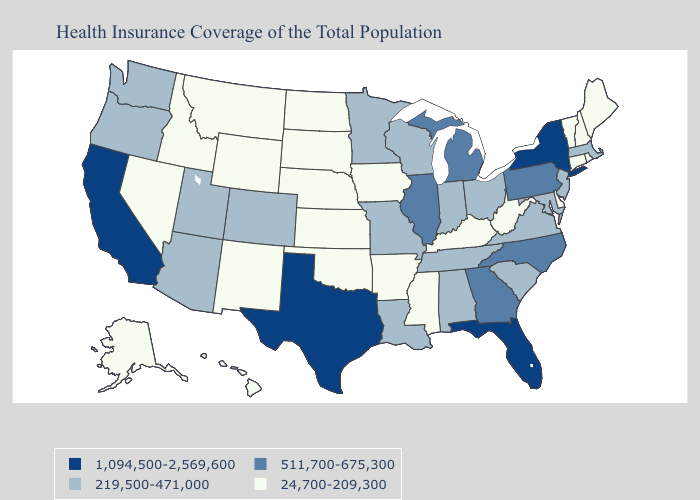Does Pennsylvania have the lowest value in the Northeast?
Be succinct. No. Name the states that have a value in the range 1,094,500-2,569,600?
Be succinct. California, Florida, New York, Texas. Name the states that have a value in the range 219,500-471,000?
Answer briefly. Alabama, Arizona, Colorado, Indiana, Louisiana, Maryland, Massachusetts, Minnesota, Missouri, New Jersey, Ohio, Oregon, South Carolina, Tennessee, Utah, Virginia, Washington, Wisconsin. Among the states that border New Hampshire , which have the lowest value?
Short answer required. Maine, Vermont. What is the value of New Hampshire?
Keep it brief. 24,700-209,300. What is the value of New Mexico?
Be succinct. 24,700-209,300. How many symbols are there in the legend?
Short answer required. 4. Among the states that border Virginia , does Kentucky have the lowest value?
Answer briefly. Yes. Name the states that have a value in the range 1,094,500-2,569,600?
Be succinct. California, Florida, New York, Texas. Name the states that have a value in the range 1,094,500-2,569,600?
Answer briefly. California, Florida, New York, Texas. Does the first symbol in the legend represent the smallest category?
Write a very short answer. No. Does Georgia have the lowest value in the South?
Short answer required. No. Name the states that have a value in the range 1,094,500-2,569,600?
Answer briefly. California, Florida, New York, Texas. Name the states that have a value in the range 219,500-471,000?
Quick response, please. Alabama, Arizona, Colorado, Indiana, Louisiana, Maryland, Massachusetts, Minnesota, Missouri, New Jersey, Ohio, Oregon, South Carolina, Tennessee, Utah, Virginia, Washington, Wisconsin. Name the states that have a value in the range 219,500-471,000?
Short answer required. Alabama, Arizona, Colorado, Indiana, Louisiana, Maryland, Massachusetts, Minnesota, Missouri, New Jersey, Ohio, Oregon, South Carolina, Tennessee, Utah, Virginia, Washington, Wisconsin. 